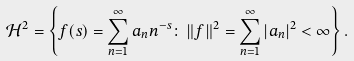<formula> <loc_0><loc_0><loc_500><loc_500>\mathcal { H } ^ { 2 } = \left \{ f ( s ) = \sum _ { n = 1 } ^ { \infty } a _ { n } n ^ { - s } \colon \, \| f \| ^ { 2 } = \sum _ { n = 1 } ^ { \infty } | a _ { n } | ^ { 2 } < \infty \right \} .</formula> 